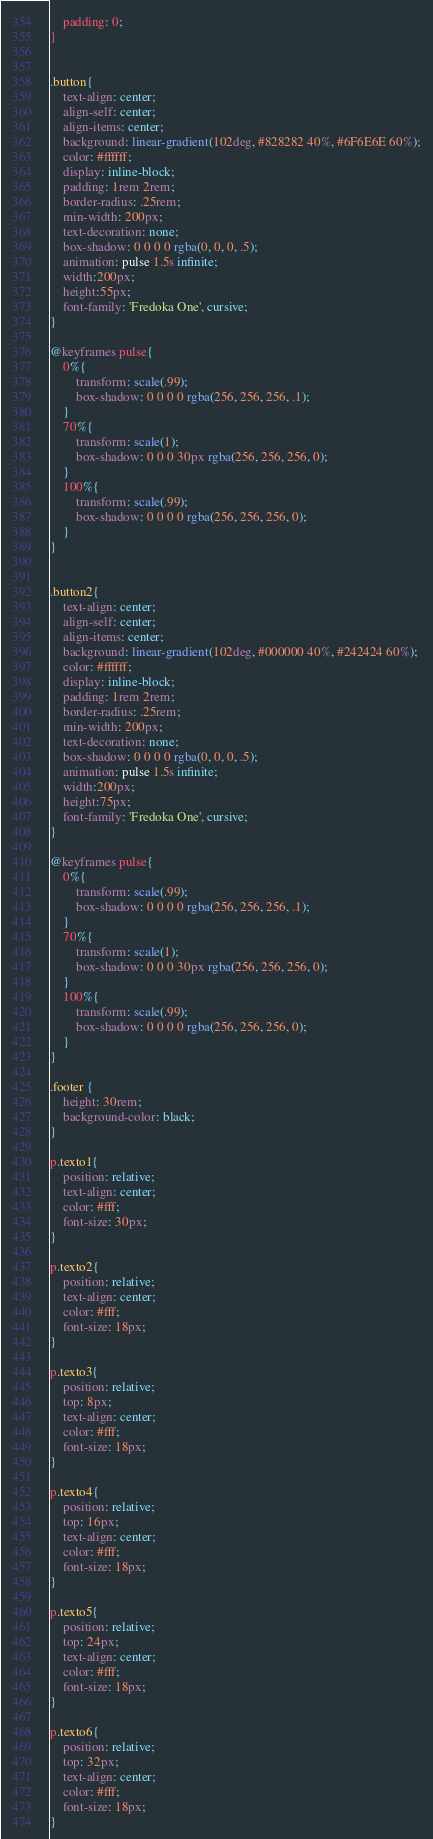<code> <loc_0><loc_0><loc_500><loc_500><_CSS_>	padding: 0;
}


.button{
	text-align: center;
	align-self: center;
	align-items: center;
	background: linear-gradient(102deg, #828282 40%, #6F6E6E 60%);
	color: #ffffff;
	display: inline-block;
	padding: 1rem 2rem;
	border-radius: .25rem;
	min-width: 200px;
	text-decoration: none;
	box-shadow: 0 0 0 0 rgba(0, 0, 0, .5);
	animation: pulse 1.5s infinite;
	width:200px;
	height:55px;
	font-family: 'Fredoka One', cursive;
}

@keyframes pulse{
	0%{
		transform: scale(.99);
		box-shadow: 0 0 0 0 rgba(256, 256, 256, .1);	
	}
	70%{
		transform: scale(1);
		box-shadow: 0 0 0 30px rgba(256, 256, 256, 0);	
	}
	100%{
		transform: scale(.99);
		box-shadow: 0 0 0 0 rgba(256, 256, 256, 0);	
	}
}								 


.button2{
	text-align: center;
	align-self: center;
	align-items: center;
	background: linear-gradient(102deg, #000000 40%, #242424 60%);
	color: #ffffff;
	display: inline-block;
	padding: 1rem 2rem;
	border-radius: .25rem;
	min-width: 200px;
	text-decoration: none;
	box-shadow: 0 0 0 0 rgba(0, 0, 0, .5);
	animation: pulse 1.5s infinite;
	width:200px;
	height:75px;
	font-family: 'Fredoka One', cursive;
}

@keyframes pulse{
	0%{
		transform: scale(.99);
		box-shadow: 0 0 0 0 rgba(256, 256, 256, .1);	
	}
	70%{
		transform: scale(1);
		box-shadow: 0 0 0 30px rgba(256, 256, 256, 0);	
	}
	100%{
		transform: scale(.99);
		box-shadow: 0 0 0 0 rgba(256, 256, 256, 0);	
	}
}

.footer {
	height: 30rem;
	background-color: black;
}

p.texto1{
	position: relative;
	text-align: center;
	color: #fff;
	font-size: 30px;
}

p.texto2{
	position: relative;
	text-align: center;
	color: #fff;
	font-size: 18px;
}

p.texto3{
	position: relative;
	top: 8px;
	text-align: center;
	color: #fff;
	font-size: 18px;
}

p.texto4{
	position: relative;
	top: 16px;
	text-align: center;
	color: #fff;
	font-size: 18px;
}

p.texto5{
	position: relative;
	top: 24px;
	text-align: center;
	color: #fff;
	font-size: 18px;
}

p.texto6{
	position: relative;
	top: 32px;
	text-align: center;
	color: #fff;
	font-size: 18px;
}



</code> 